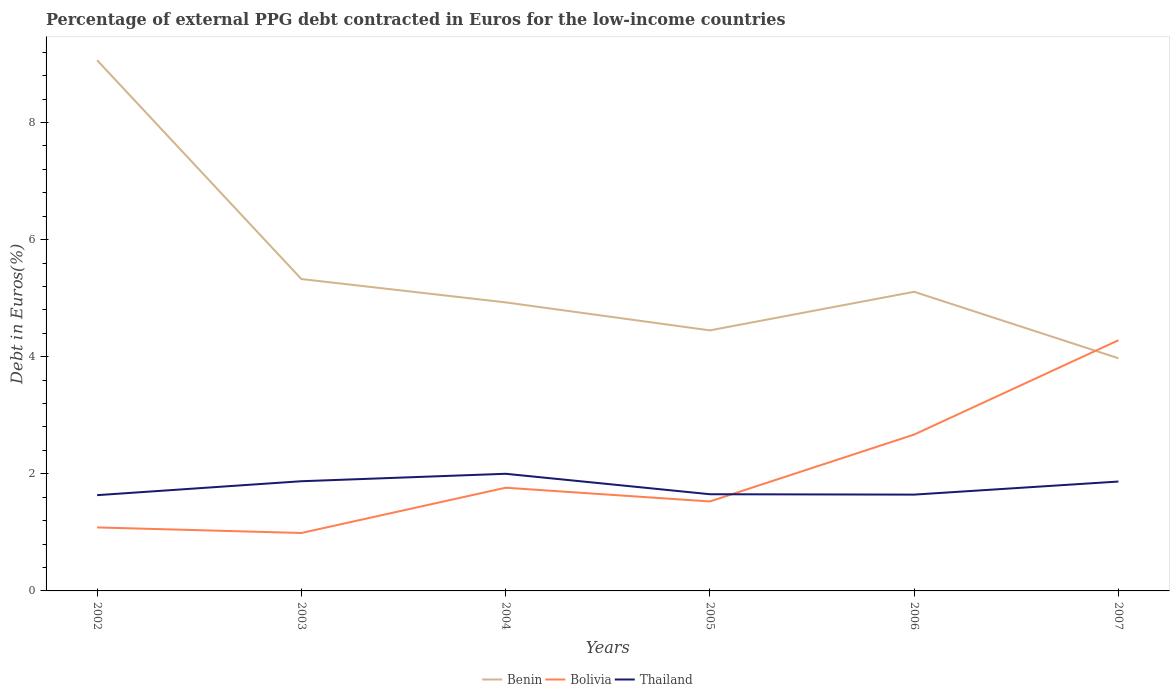Does the line corresponding to Benin intersect with the line corresponding to Thailand?
Ensure brevity in your answer.  No. Across all years, what is the maximum percentage of external PPG debt contracted in Euros in Benin?
Keep it short and to the point. 3.97. What is the total percentage of external PPG debt contracted in Euros in Thailand in the graph?
Provide a succinct answer. 0.01. What is the difference between the highest and the second highest percentage of external PPG debt contracted in Euros in Benin?
Provide a succinct answer. 5.09. How many lines are there?
Offer a terse response. 3. What is the difference between two consecutive major ticks on the Y-axis?
Make the answer very short. 2. How are the legend labels stacked?
Keep it short and to the point. Horizontal. What is the title of the graph?
Your answer should be very brief. Percentage of external PPG debt contracted in Euros for the low-income countries. Does "Italy" appear as one of the legend labels in the graph?
Offer a terse response. No. What is the label or title of the X-axis?
Give a very brief answer. Years. What is the label or title of the Y-axis?
Ensure brevity in your answer.  Debt in Euros(%). What is the Debt in Euros(%) of Benin in 2002?
Your response must be concise. 9.06. What is the Debt in Euros(%) of Bolivia in 2002?
Your answer should be very brief. 1.08. What is the Debt in Euros(%) in Thailand in 2002?
Your answer should be compact. 1.64. What is the Debt in Euros(%) in Benin in 2003?
Make the answer very short. 5.33. What is the Debt in Euros(%) in Bolivia in 2003?
Offer a terse response. 0.99. What is the Debt in Euros(%) of Thailand in 2003?
Ensure brevity in your answer.  1.87. What is the Debt in Euros(%) of Benin in 2004?
Your answer should be very brief. 4.93. What is the Debt in Euros(%) of Bolivia in 2004?
Keep it short and to the point. 1.76. What is the Debt in Euros(%) in Thailand in 2004?
Give a very brief answer. 2. What is the Debt in Euros(%) in Benin in 2005?
Keep it short and to the point. 4.45. What is the Debt in Euros(%) in Bolivia in 2005?
Offer a very short reply. 1.53. What is the Debt in Euros(%) in Thailand in 2005?
Offer a very short reply. 1.65. What is the Debt in Euros(%) in Benin in 2006?
Your answer should be compact. 5.11. What is the Debt in Euros(%) of Bolivia in 2006?
Give a very brief answer. 2.67. What is the Debt in Euros(%) in Thailand in 2006?
Offer a very short reply. 1.64. What is the Debt in Euros(%) of Benin in 2007?
Your answer should be very brief. 3.97. What is the Debt in Euros(%) of Bolivia in 2007?
Keep it short and to the point. 4.28. What is the Debt in Euros(%) of Thailand in 2007?
Make the answer very short. 1.87. Across all years, what is the maximum Debt in Euros(%) of Benin?
Provide a succinct answer. 9.06. Across all years, what is the maximum Debt in Euros(%) of Bolivia?
Your response must be concise. 4.28. Across all years, what is the maximum Debt in Euros(%) in Thailand?
Give a very brief answer. 2. Across all years, what is the minimum Debt in Euros(%) of Benin?
Offer a terse response. 3.97. Across all years, what is the minimum Debt in Euros(%) of Bolivia?
Your answer should be compact. 0.99. Across all years, what is the minimum Debt in Euros(%) in Thailand?
Make the answer very short. 1.64. What is the total Debt in Euros(%) of Benin in the graph?
Offer a terse response. 32.85. What is the total Debt in Euros(%) of Bolivia in the graph?
Ensure brevity in your answer.  12.32. What is the total Debt in Euros(%) of Thailand in the graph?
Provide a short and direct response. 10.67. What is the difference between the Debt in Euros(%) of Benin in 2002 and that in 2003?
Your answer should be very brief. 3.74. What is the difference between the Debt in Euros(%) of Bolivia in 2002 and that in 2003?
Ensure brevity in your answer.  0.09. What is the difference between the Debt in Euros(%) of Thailand in 2002 and that in 2003?
Your response must be concise. -0.24. What is the difference between the Debt in Euros(%) of Benin in 2002 and that in 2004?
Keep it short and to the point. 4.14. What is the difference between the Debt in Euros(%) in Bolivia in 2002 and that in 2004?
Offer a very short reply. -0.68. What is the difference between the Debt in Euros(%) of Thailand in 2002 and that in 2004?
Make the answer very short. -0.37. What is the difference between the Debt in Euros(%) in Benin in 2002 and that in 2005?
Ensure brevity in your answer.  4.61. What is the difference between the Debt in Euros(%) of Bolivia in 2002 and that in 2005?
Give a very brief answer. -0.44. What is the difference between the Debt in Euros(%) in Thailand in 2002 and that in 2005?
Your response must be concise. -0.02. What is the difference between the Debt in Euros(%) of Benin in 2002 and that in 2006?
Keep it short and to the point. 3.95. What is the difference between the Debt in Euros(%) in Bolivia in 2002 and that in 2006?
Your response must be concise. -1.59. What is the difference between the Debt in Euros(%) of Thailand in 2002 and that in 2006?
Provide a succinct answer. -0.01. What is the difference between the Debt in Euros(%) in Benin in 2002 and that in 2007?
Keep it short and to the point. 5.09. What is the difference between the Debt in Euros(%) of Bolivia in 2002 and that in 2007?
Offer a terse response. -3.2. What is the difference between the Debt in Euros(%) in Thailand in 2002 and that in 2007?
Offer a very short reply. -0.23. What is the difference between the Debt in Euros(%) in Benin in 2003 and that in 2004?
Offer a terse response. 0.4. What is the difference between the Debt in Euros(%) in Bolivia in 2003 and that in 2004?
Your response must be concise. -0.77. What is the difference between the Debt in Euros(%) in Thailand in 2003 and that in 2004?
Keep it short and to the point. -0.13. What is the difference between the Debt in Euros(%) in Benin in 2003 and that in 2005?
Make the answer very short. 0.88. What is the difference between the Debt in Euros(%) of Bolivia in 2003 and that in 2005?
Your answer should be compact. -0.54. What is the difference between the Debt in Euros(%) in Thailand in 2003 and that in 2005?
Give a very brief answer. 0.22. What is the difference between the Debt in Euros(%) of Benin in 2003 and that in 2006?
Your answer should be compact. 0.22. What is the difference between the Debt in Euros(%) in Bolivia in 2003 and that in 2006?
Offer a terse response. -1.68. What is the difference between the Debt in Euros(%) of Thailand in 2003 and that in 2006?
Your response must be concise. 0.23. What is the difference between the Debt in Euros(%) in Benin in 2003 and that in 2007?
Your response must be concise. 1.35. What is the difference between the Debt in Euros(%) of Bolivia in 2003 and that in 2007?
Provide a succinct answer. -3.29. What is the difference between the Debt in Euros(%) in Thailand in 2003 and that in 2007?
Offer a terse response. 0.01. What is the difference between the Debt in Euros(%) in Benin in 2004 and that in 2005?
Give a very brief answer. 0.48. What is the difference between the Debt in Euros(%) of Bolivia in 2004 and that in 2005?
Ensure brevity in your answer.  0.23. What is the difference between the Debt in Euros(%) in Thailand in 2004 and that in 2005?
Your answer should be compact. 0.35. What is the difference between the Debt in Euros(%) of Benin in 2004 and that in 2006?
Your response must be concise. -0.18. What is the difference between the Debt in Euros(%) in Bolivia in 2004 and that in 2006?
Provide a short and direct response. -0.91. What is the difference between the Debt in Euros(%) in Thailand in 2004 and that in 2006?
Give a very brief answer. 0.36. What is the difference between the Debt in Euros(%) of Benin in 2004 and that in 2007?
Offer a very short reply. 0.95. What is the difference between the Debt in Euros(%) in Bolivia in 2004 and that in 2007?
Give a very brief answer. -2.52. What is the difference between the Debt in Euros(%) of Thailand in 2004 and that in 2007?
Make the answer very short. 0.13. What is the difference between the Debt in Euros(%) of Benin in 2005 and that in 2006?
Ensure brevity in your answer.  -0.66. What is the difference between the Debt in Euros(%) of Bolivia in 2005 and that in 2006?
Keep it short and to the point. -1.14. What is the difference between the Debt in Euros(%) of Thailand in 2005 and that in 2006?
Provide a succinct answer. 0.01. What is the difference between the Debt in Euros(%) of Benin in 2005 and that in 2007?
Give a very brief answer. 0.48. What is the difference between the Debt in Euros(%) of Bolivia in 2005 and that in 2007?
Provide a succinct answer. -2.75. What is the difference between the Debt in Euros(%) of Thailand in 2005 and that in 2007?
Offer a terse response. -0.22. What is the difference between the Debt in Euros(%) in Benin in 2006 and that in 2007?
Offer a very short reply. 1.14. What is the difference between the Debt in Euros(%) of Bolivia in 2006 and that in 2007?
Give a very brief answer. -1.61. What is the difference between the Debt in Euros(%) in Thailand in 2006 and that in 2007?
Provide a succinct answer. -0.22. What is the difference between the Debt in Euros(%) of Benin in 2002 and the Debt in Euros(%) of Bolivia in 2003?
Make the answer very short. 8.07. What is the difference between the Debt in Euros(%) of Benin in 2002 and the Debt in Euros(%) of Thailand in 2003?
Your answer should be very brief. 7.19. What is the difference between the Debt in Euros(%) in Bolivia in 2002 and the Debt in Euros(%) in Thailand in 2003?
Your answer should be compact. -0.79. What is the difference between the Debt in Euros(%) in Benin in 2002 and the Debt in Euros(%) in Bolivia in 2004?
Offer a very short reply. 7.3. What is the difference between the Debt in Euros(%) of Benin in 2002 and the Debt in Euros(%) of Thailand in 2004?
Provide a short and direct response. 7.06. What is the difference between the Debt in Euros(%) in Bolivia in 2002 and the Debt in Euros(%) in Thailand in 2004?
Keep it short and to the point. -0.92. What is the difference between the Debt in Euros(%) in Benin in 2002 and the Debt in Euros(%) in Bolivia in 2005?
Give a very brief answer. 7.54. What is the difference between the Debt in Euros(%) in Benin in 2002 and the Debt in Euros(%) in Thailand in 2005?
Offer a terse response. 7.41. What is the difference between the Debt in Euros(%) of Bolivia in 2002 and the Debt in Euros(%) of Thailand in 2005?
Offer a terse response. -0.57. What is the difference between the Debt in Euros(%) in Benin in 2002 and the Debt in Euros(%) in Bolivia in 2006?
Keep it short and to the point. 6.39. What is the difference between the Debt in Euros(%) in Benin in 2002 and the Debt in Euros(%) in Thailand in 2006?
Provide a succinct answer. 7.42. What is the difference between the Debt in Euros(%) of Bolivia in 2002 and the Debt in Euros(%) of Thailand in 2006?
Your answer should be compact. -0.56. What is the difference between the Debt in Euros(%) in Benin in 2002 and the Debt in Euros(%) in Bolivia in 2007?
Make the answer very short. 4.78. What is the difference between the Debt in Euros(%) in Benin in 2002 and the Debt in Euros(%) in Thailand in 2007?
Offer a very short reply. 7.2. What is the difference between the Debt in Euros(%) in Bolivia in 2002 and the Debt in Euros(%) in Thailand in 2007?
Offer a very short reply. -0.78. What is the difference between the Debt in Euros(%) of Benin in 2003 and the Debt in Euros(%) of Bolivia in 2004?
Your answer should be very brief. 3.56. What is the difference between the Debt in Euros(%) of Benin in 2003 and the Debt in Euros(%) of Thailand in 2004?
Offer a very short reply. 3.33. What is the difference between the Debt in Euros(%) of Bolivia in 2003 and the Debt in Euros(%) of Thailand in 2004?
Provide a short and direct response. -1.01. What is the difference between the Debt in Euros(%) of Benin in 2003 and the Debt in Euros(%) of Bolivia in 2005?
Make the answer very short. 3.8. What is the difference between the Debt in Euros(%) in Benin in 2003 and the Debt in Euros(%) in Thailand in 2005?
Offer a terse response. 3.67. What is the difference between the Debt in Euros(%) in Bolivia in 2003 and the Debt in Euros(%) in Thailand in 2005?
Provide a succinct answer. -0.66. What is the difference between the Debt in Euros(%) in Benin in 2003 and the Debt in Euros(%) in Bolivia in 2006?
Your answer should be compact. 2.66. What is the difference between the Debt in Euros(%) of Benin in 2003 and the Debt in Euros(%) of Thailand in 2006?
Offer a terse response. 3.68. What is the difference between the Debt in Euros(%) of Bolivia in 2003 and the Debt in Euros(%) of Thailand in 2006?
Your response must be concise. -0.66. What is the difference between the Debt in Euros(%) in Benin in 2003 and the Debt in Euros(%) in Bolivia in 2007?
Your response must be concise. 1.05. What is the difference between the Debt in Euros(%) of Benin in 2003 and the Debt in Euros(%) of Thailand in 2007?
Provide a succinct answer. 3.46. What is the difference between the Debt in Euros(%) of Bolivia in 2003 and the Debt in Euros(%) of Thailand in 2007?
Your answer should be compact. -0.88. What is the difference between the Debt in Euros(%) in Benin in 2004 and the Debt in Euros(%) in Bolivia in 2005?
Offer a terse response. 3.4. What is the difference between the Debt in Euros(%) of Benin in 2004 and the Debt in Euros(%) of Thailand in 2005?
Offer a terse response. 3.28. What is the difference between the Debt in Euros(%) of Bolivia in 2004 and the Debt in Euros(%) of Thailand in 2005?
Make the answer very short. 0.11. What is the difference between the Debt in Euros(%) in Benin in 2004 and the Debt in Euros(%) in Bolivia in 2006?
Provide a succinct answer. 2.26. What is the difference between the Debt in Euros(%) of Benin in 2004 and the Debt in Euros(%) of Thailand in 2006?
Provide a succinct answer. 3.28. What is the difference between the Debt in Euros(%) in Bolivia in 2004 and the Debt in Euros(%) in Thailand in 2006?
Give a very brief answer. 0.12. What is the difference between the Debt in Euros(%) of Benin in 2004 and the Debt in Euros(%) of Bolivia in 2007?
Provide a short and direct response. 0.65. What is the difference between the Debt in Euros(%) in Benin in 2004 and the Debt in Euros(%) in Thailand in 2007?
Provide a succinct answer. 3.06. What is the difference between the Debt in Euros(%) in Bolivia in 2004 and the Debt in Euros(%) in Thailand in 2007?
Ensure brevity in your answer.  -0.11. What is the difference between the Debt in Euros(%) of Benin in 2005 and the Debt in Euros(%) of Bolivia in 2006?
Keep it short and to the point. 1.78. What is the difference between the Debt in Euros(%) of Benin in 2005 and the Debt in Euros(%) of Thailand in 2006?
Offer a very short reply. 2.8. What is the difference between the Debt in Euros(%) of Bolivia in 2005 and the Debt in Euros(%) of Thailand in 2006?
Provide a short and direct response. -0.12. What is the difference between the Debt in Euros(%) in Benin in 2005 and the Debt in Euros(%) in Bolivia in 2007?
Keep it short and to the point. 0.17. What is the difference between the Debt in Euros(%) of Benin in 2005 and the Debt in Euros(%) of Thailand in 2007?
Ensure brevity in your answer.  2.58. What is the difference between the Debt in Euros(%) of Bolivia in 2005 and the Debt in Euros(%) of Thailand in 2007?
Your answer should be very brief. -0.34. What is the difference between the Debt in Euros(%) of Benin in 2006 and the Debt in Euros(%) of Bolivia in 2007?
Offer a very short reply. 0.83. What is the difference between the Debt in Euros(%) of Benin in 2006 and the Debt in Euros(%) of Thailand in 2007?
Provide a short and direct response. 3.24. What is the difference between the Debt in Euros(%) in Bolivia in 2006 and the Debt in Euros(%) in Thailand in 2007?
Offer a terse response. 0.8. What is the average Debt in Euros(%) of Benin per year?
Your answer should be very brief. 5.47. What is the average Debt in Euros(%) in Bolivia per year?
Your response must be concise. 2.05. What is the average Debt in Euros(%) in Thailand per year?
Your answer should be very brief. 1.78. In the year 2002, what is the difference between the Debt in Euros(%) in Benin and Debt in Euros(%) in Bolivia?
Offer a terse response. 7.98. In the year 2002, what is the difference between the Debt in Euros(%) of Benin and Debt in Euros(%) of Thailand?
Give a very brief answer. 7.43. In the year 2002, what is the difference between the Debt in Euros(%) of Bolivia and Debt in Euros(%) of Thailand?
Give a very brief answer. -0.55. In the year 2003, what is the difference between the Debt in Euros(%) of Benin and Debt in Euros(%) of Bolivia?
Ensure brevity in your answer.  4.34. In the year 2003, what is the difference between the Debt in Euros(%) in Benin and Debt in Euros(%) in Thailand?
Provide a succinct answer. 3.45. In the year 2003, what is the difference between the Debt in Euros(%) of Bolivia and Debt in Euros(%) of Thailand?
Provide a short and direct response. -0.88. In the year 2004, what is the difference between the Debt in Euros(%) in Benin and Debt in Euros(%) in Bolivia?
Your answer should be very brief. 3.17. In the year 2004, what is the difference between the Debt in Euros(%) of Benin and Debt in Euros(%) of Thailand?
Offer a very short reply. 2.93. In the year 2004, what is the difference between the Debt in Euros(%) in Bolivia and Debt in Euros(%) in Thailand?
Provide a succinct answer. -0.24. In the year 2005, what is the difference between the Debt in Euros(%) of Benin and Debt in Euros(%) of Bolivia?
Make the answer very short. 2.92. In the year 2005, what is the difference between the Debt in Euros(%) in Benin and Debt in Euros(%) in Thailand?
Offer a very short reply. 2.8. In the year 2005, what is the difference between the Debt in Euros(%) of Bolivia and Debt in Euros(%) of Thailand?
Ensure brevity in your answer.  -0.12. In the year 2006, what is the difference between the Debt in Euros(%) of Benin and Debt in Euros(%) of Bolivia?
Keep it short and to the point. 2.44. In the year 2006, what is the difference between the Debt in Euros(%) of Benin and Debt in Euros(%) of Thailand?
Provide a short and direct response. 3.46. In the year 2006, what is the difference between the Debt in Euros(%) in Bolivia and Debt in Euros(%) in Thailand?
Offer a terse response. 1.03. In the year 2007, what is the difference between the Debt in Euros(%) in Benin and Debt in Euros(%) in Bolivia?
Your response must be concise. -0.31. In the year 2007, what is the difference between the Debt in Euros(%) of Benin and Debt in Euros(%) of Thailand?
Provide a short and direct response. 2.11. In the year 2007, what is the difference between the Debt in Euros(%) in Bolivia and Debt in Euros(%) in Thailand?
Offer a terse response. 2.41. What is the ratio of the Debt in Euros(%) of Benin in 2002 to that in 2003?
Provide a short and direct response. 1.7. What is the ratio of the Debt in Euros(%) in Bolivia in 2002 to that in 2003?
Offer a terse response. 1.1. What is the ratio of the Debt in Euros(%) of Thailand in 2002 to that in 2003?
Give a very brief answer. 0.87. What is the ratio of the Debt in Euros(%) of Benin in 2002 to that in 2004?
Give a very brief answer. 1.84. What is the ratio of the Debt in Euros(%) in Bolivia in 2002 to that in 2004?
Provide a short and direct response. 0.62. What is the ratio of the Debt in Euros(%) of Thailand in 2002 to that in 2004?
Make the answer very short. 0.82. What is the ratio of the Debt in Euros(%) in Benin in 2002 to that in 2005?
Your answer should be very brief. 2.04. What is the ratio of the Debt in Euros(%) of Bolivia in 2002 to that in 2005?
Ensure brevity in your answer.  0.71. What is the ratio of the Debt in Euros(%) in Thailand in 2002 to that in 2005?
Offer a very short reply. 0.99. What is the ratio of the Debt in Euros(%) in Benin in 2002 to that in 2006?
Your answer should be very brief. 1.77. What is the ratio of the Debt in Euros(%) in Bolivia in 2002 to that in 2006?
Keep it short and to the point. 0.41. What is the ratio of the Debt in Euros(%) of Thailand in 2002 to that in 2006?
Make the answer very short. 0.99. What is the ratio of the Debt in Euros(%) in Benin in 2002 to that in 2007?
Make the answer very short. 2.28. What is the ratio of the Debt in Euros(%) of Bolivia in 2002 to that in 2007?
Your answer should be very brief. 0.25. What is the ratio of the Debt in Euros(%) in Thailand in 2002 to that in 2007?
Your response must be concise. 0.88. What is the ratio of the Debt in Euros(%) in Benin in 2003 to that in 2004?
Your answer should be very brief. 1.08. What is the ratio of the Debt in Euros(%) in Bolivia in 2003 to that in 2004?
Your answer should be very brief. 0.56. What is the ratio of the Debt in Euros(%) of Thailand in 2003 to that in 2004?
Make the answer very short. 0.94. What is the ratio of the Debt in Euros(%) in Benin in 2003 to that in 2005?
Give a very brief answer. 1.2. What is the ratio of the Debt in Euros(%) in Bolivia in 2003 to that in 2005?
Your response must be concise. 0.65. What is the ratio of the Debt in Euros(%) of Thailand in 2003 to that in 2005?
Provide a short and direct response. 1.13. What is the ratio of the Debt in Euros(%) in Benin in 2003 to that in 2006?
Your answer should be very brief. 1.04. What is the ratio of the Debt in Euros(%) of Bolivia in 2003 to that in 2006?
Your answer should be compact. 0.37. What is the ratio of the Debt in Euros(%) of Thailand in 2003 to that in 2006?
Ensure brevity in your answer.  1.14. What is the ratio of the Debt in Euros(%) of Benin in 2003 to that in 2007?
Offer a terse response. 1.34. What is the ratio of the Debt in Euros(%) in Bolivia in 2003 to that in 2007?
Give a very brief answer. 0.23. What is the ratio of the Debt in Euros(%) of Thailand in 2003 to that in 2007?
Your answer should be compact. 1. What is the ratio of the Debt in Euros(%) of Benin in 2004 to that in 2005?
Your answer should be very brief. 1.11. What is the ratio of the Debt in Euros(%) in Bolivia in 2004 to that in 2005?
Your answer should be compact. 1.15. What is the ratio of the Debt in Euros(%) of Thailand in 2004 to that in 2005?
Ensure brevity in your answer.  1.21. What is the ratio of the Debt in Euros(%) in Benin in 2004 to that in 2006?
Offer a very short reply. 0.96. What is the ratio of the Debt in Euros(%) in Bolivia in 2004 to that in 2006?
Provide a short and direct response. 0.66. What is the ratio of the Debt in Euros(%) in Thailand in 2004 to that in 2006?
Provide a succinct answer. 1.22. What is the ratio of the Debt in Euros(%) of Benin in 2004 to that in 2007?
Offer a very short reply. 1.24. What is the ratio of the Debt in Euros(%) of Bolivia in 2004 to that in 2007?
Provide a short and direct response. 0.41. What is the ratio of the Debt in Euros(%) of Thailand in 2004 to that in 2007?
Your response must be concise. 1.07. What is the ratio of the Debt in Euros(%) of Benin in 2005 to that in 2006?
Offer a very short reply. 0.87. What is the ratio of the Debt in Euros(%) in Bolivia in 2005 to that in 2006?
Your response must be concise. 0.57. What is the ratio of the Debt in Euros(%) of Benin in 2005 to that in 2007?
Provide a short and direct response. 1.12. What is the ratio of the Debt in Euros(%) in Bolivia in 2005 to that in 2007?
Make the answer very short. 0.36. What is the ratio of the Debt in Euros(%) of Thailand in 2005 to that in 2007?
Offer a terse response. 0.88. What is the ratio of the Debt in Euros(%) of Bolivia in 2006 to that in 2007?
Provide a succinct answer. 0.62. What is the ratio of the Debt in Euros(%) in Thailand in 2006 to that in 2007?
Offer a terse response. 0.88. What is the difference between the highest and the second highest Debt in Euros(%) in Benin?
Give a very brief answer. 3.74. What is the difference between the highest and the second highest Debt in Euros(%) of Bolivia?
Offer a terse response. 1.61. What is the difference between the highest and the second highest Debt in Euros(%) in Thailand?
Your answer should be very brief. 0.13. What is the difference between the highest and the lowest Debt in Euros(%) of Benin?
Your answer should be compact. 5.09. What is the difference between the highest and the lowest Debt in Euros(%) in Bolivia?
Your answer should be compact. 3.29. What is the difference between the highest and the lowest Debt in Euros(%) of Thailand?
Provide a short and direct response. 0.37. 